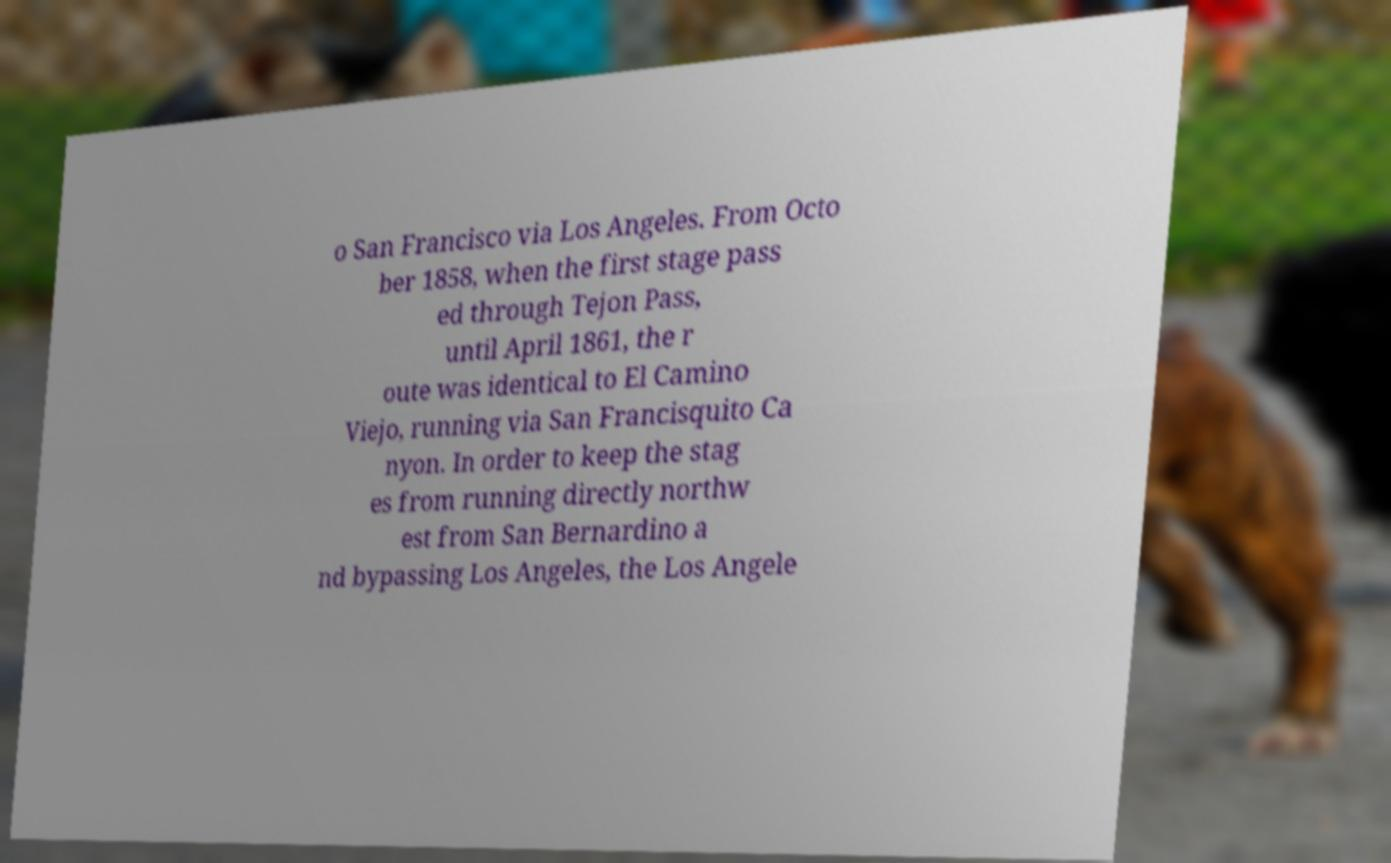Could you assist in decoding the text presented in this image and type it out clearly? o San Francisco via Los Angeles. From Octo ber 1858, when the first stage pass ed through Tejon Pass, until April 1861, the r oute was identical to El Camino Viejo, running via San Francisquito Ca nyon. In order to keep the stag es from running directly northw est from San Bernardino a nd bypassing Los Angeles, the Los Angele 